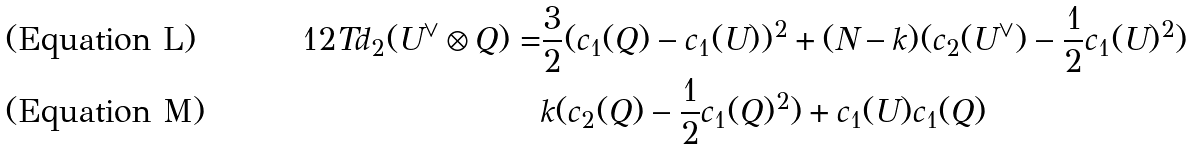Convert formula to latex. <formula><loc_0><loc_0><loc_500><loc_500>1 2 T d _ { 2 } ( U ^ { \vee } \otimes Q ) = & \frac { 3 } { 2 } ( c _ { 1 } ( Q ) - c _ { 1 } ( U ) ) ^ { 2 } + ( N - k ) ( c _ { 2 } ( U ^ { \vee } ) - \frac { 1 } { 2 } c _ { 1 } ( U ) ^ { 2 } ) \\ & k ( c _ { 2 } ( Q ) - \frac { 1 } { 2 } c _ { 1 } ( Q ) ^ { 2 } ) + c _ { 1 } ( U ) c _ { 1 } ( Q )</formula> 